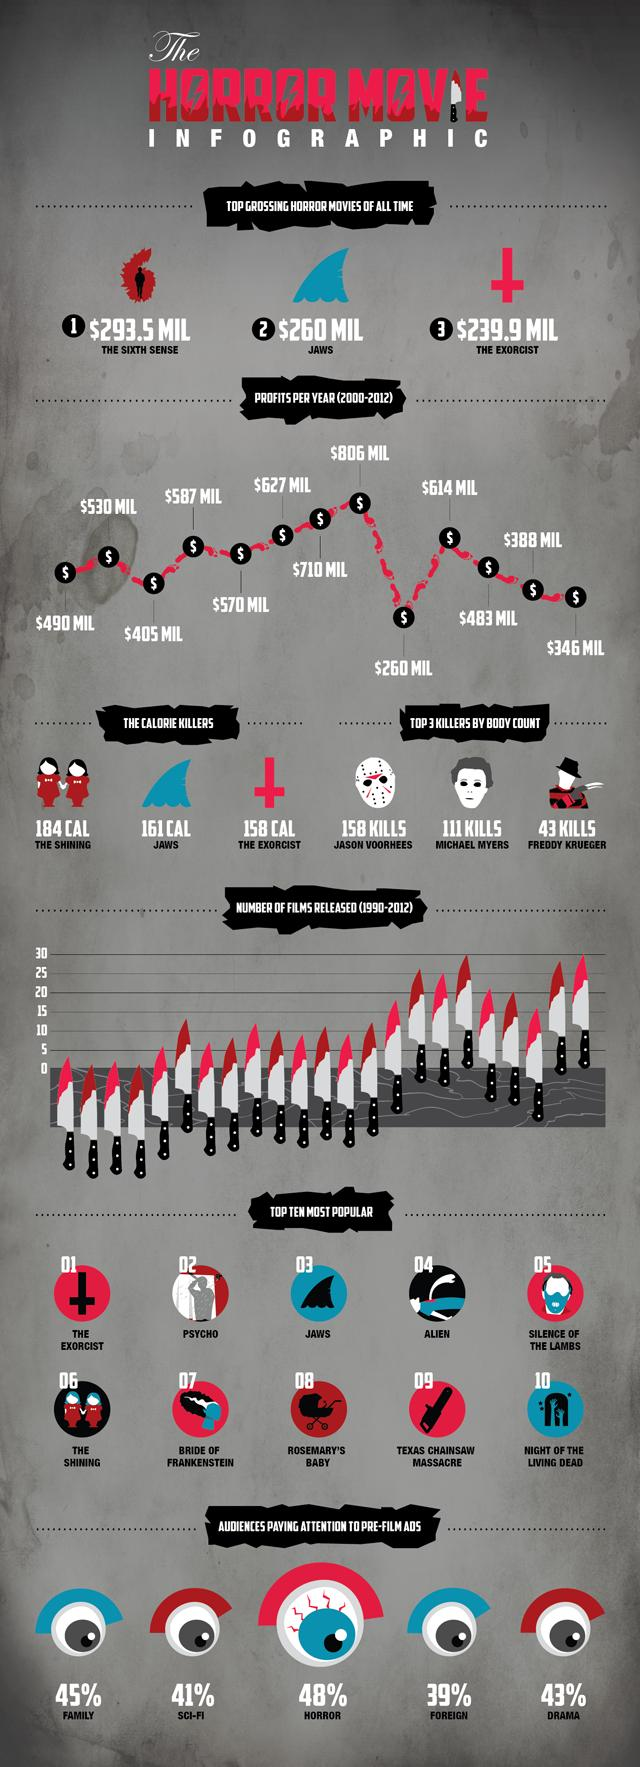Identify some key points in this picture. JASON VOORHEES was the killer who killed the most. JAWS is the second most top grossing movie of all time, followed by the movie that is currently the most top grossing. 